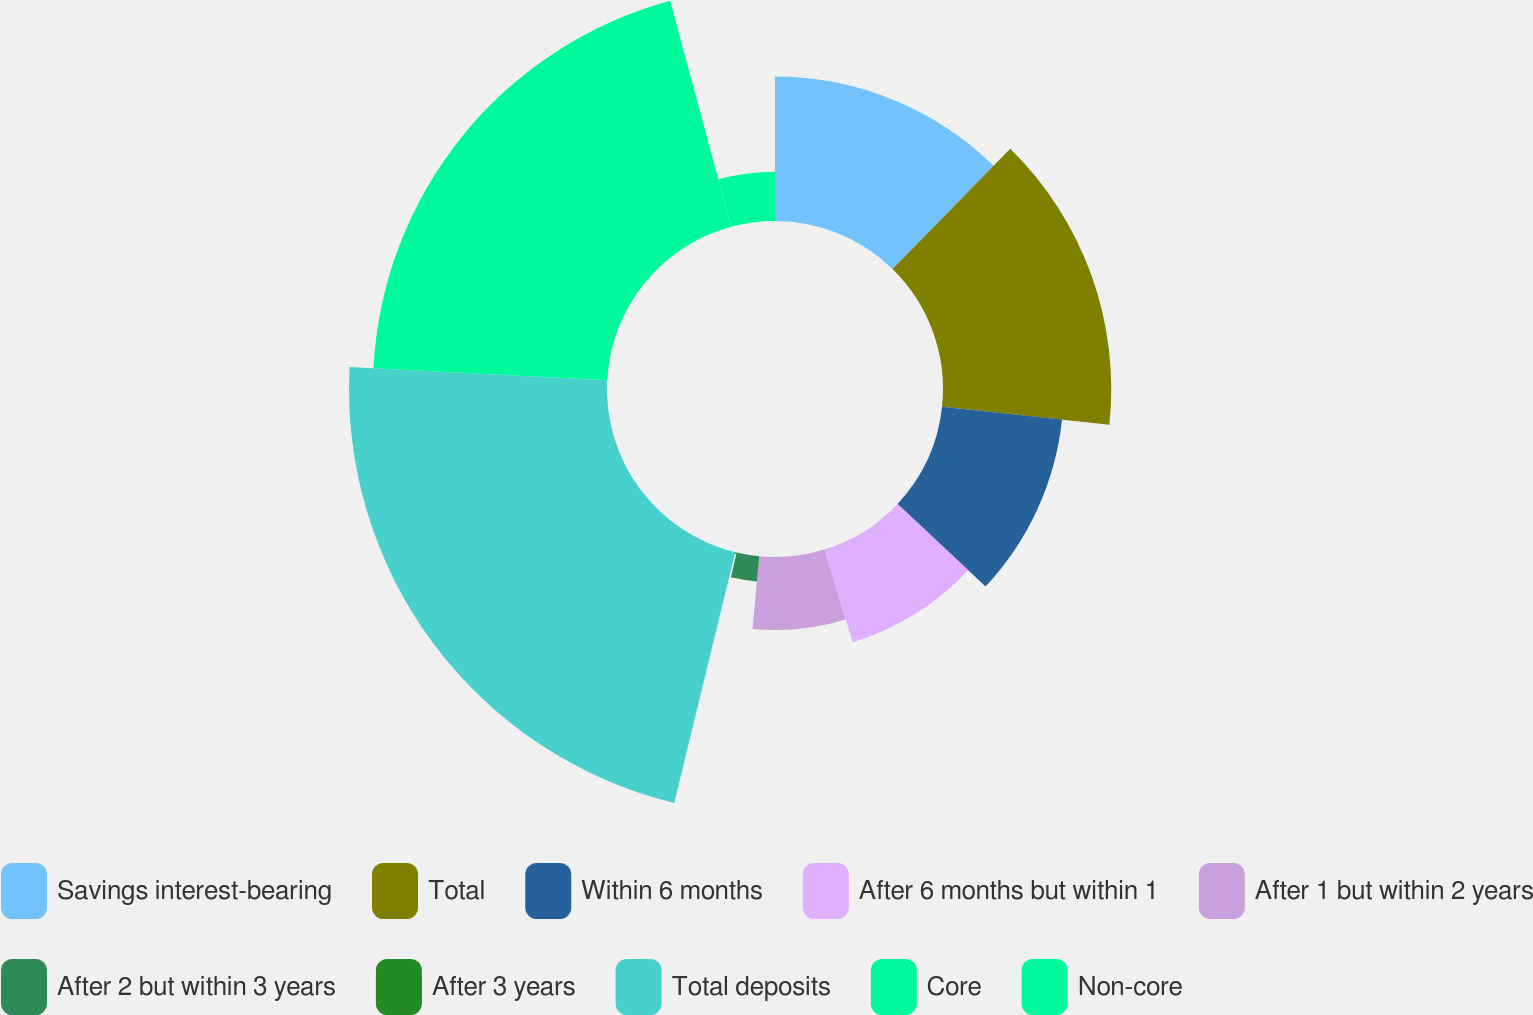<chart> <loc_0><loc_0><loc_500><loc_500><pie_chart><fcel>Savings interest-bearing<fcel>Total<fcel>Within 6 months<fcel>After 6 months but within 1<fcel>After 1 but within 2 years<fcel>After 2 but within 3 years<fcel>After 3 years<fcel>Total deposits<fcel>Core<fcel>Non-core<nl><fcel>12.33%<fcel>14.36%<fcel>10.3%<fcel>8.27%<fcel>6.23%<fcel>2.17%<fcel>0.14%<fcel>22.02%<fcel>19.98%<fcel>4.2%<nl></chart> 